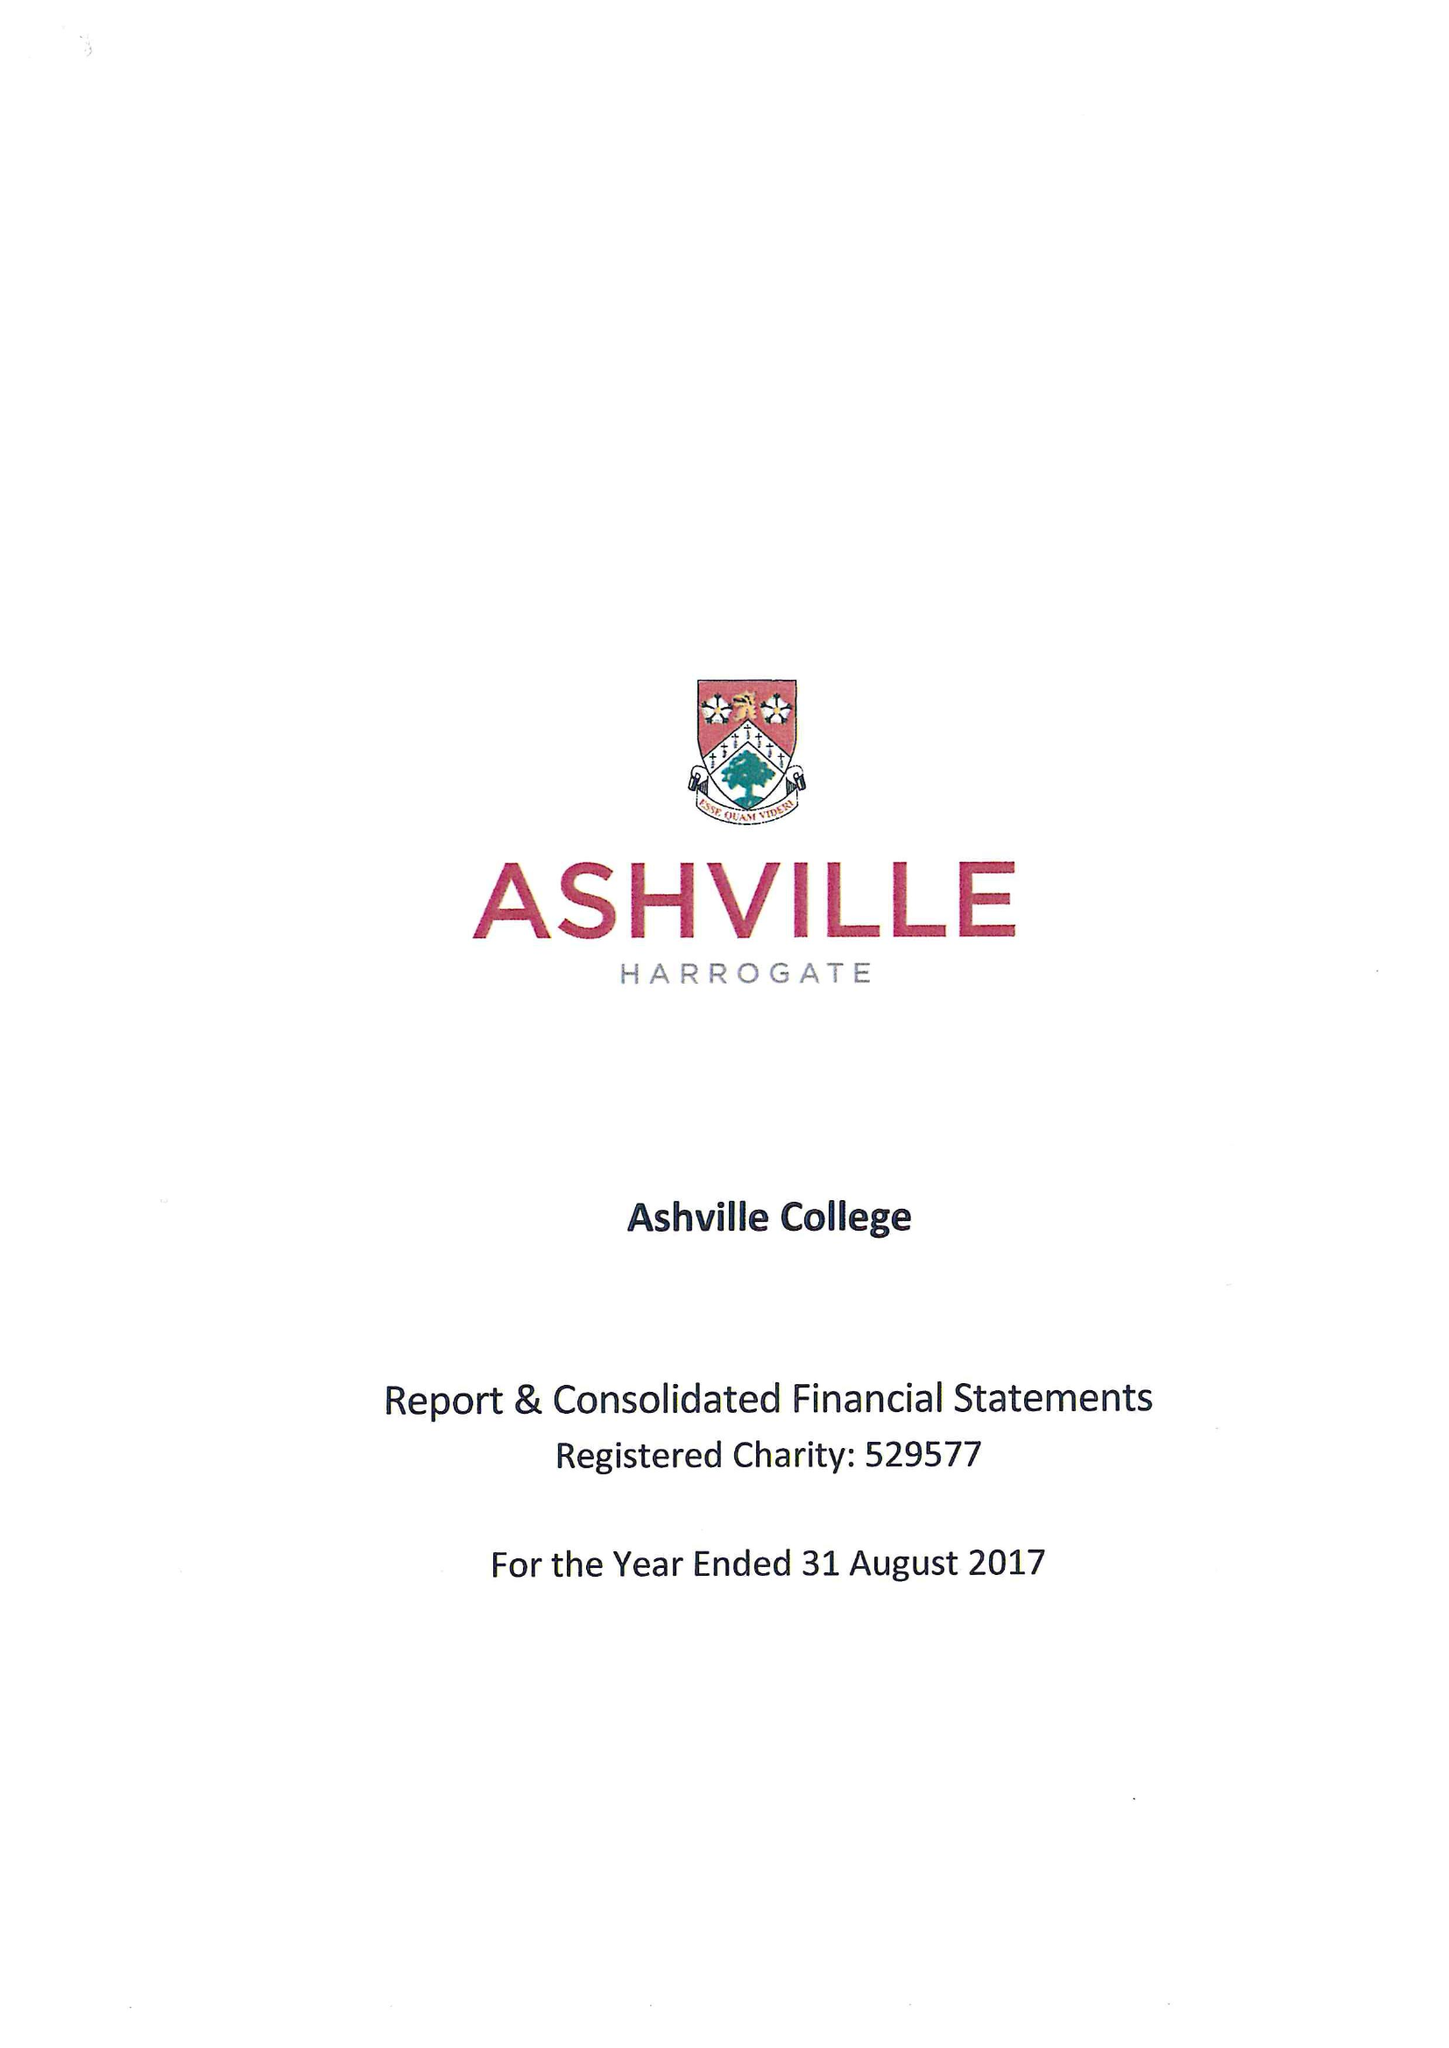What is the value for the report_date?
Answer the question using a single word or phrase. 2017-08-31 